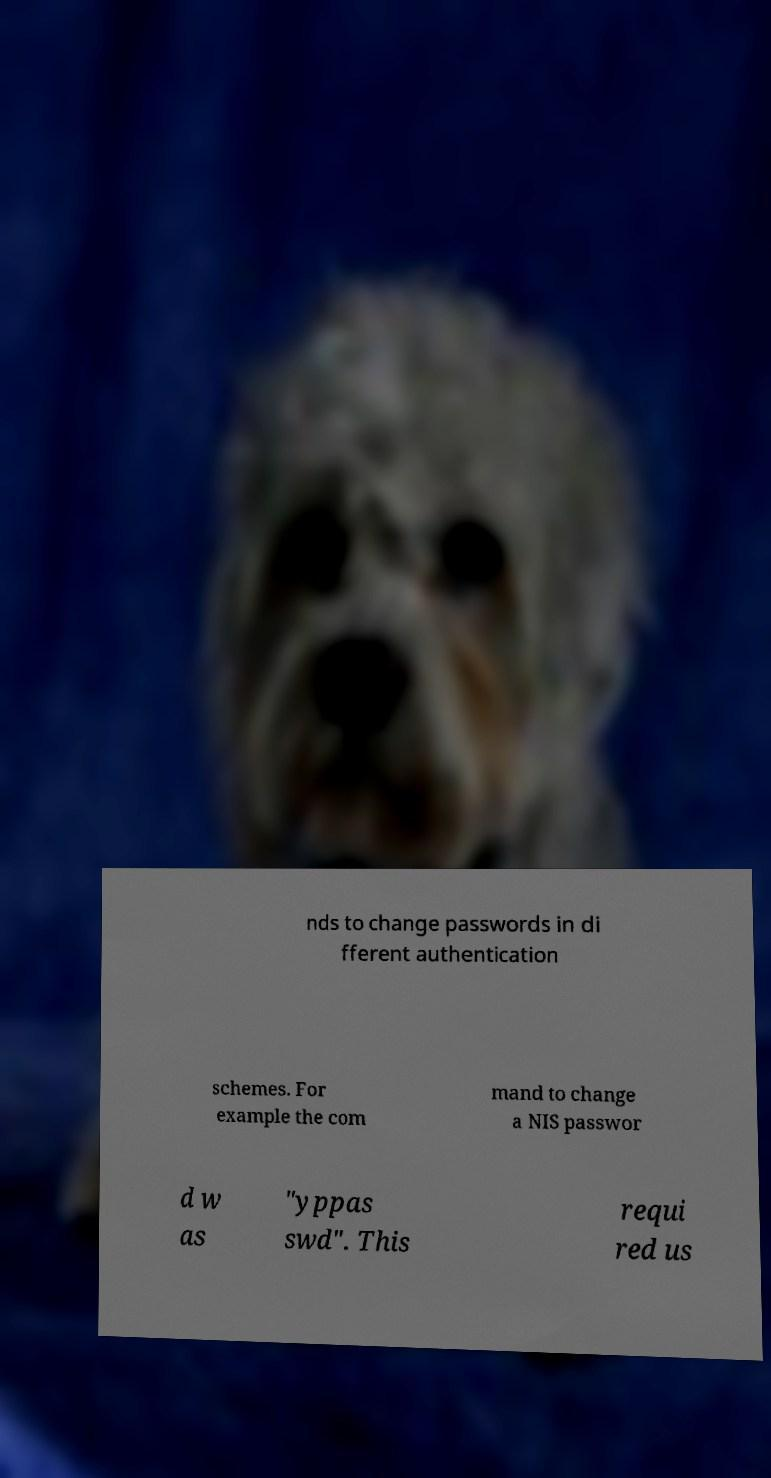I need the written content from this picture converted into text. Can you do that? nds to change passwords in di fferent authentication schemes. For example the com mand to change a NIS passwor d w as "yppas swd". This requi red us 